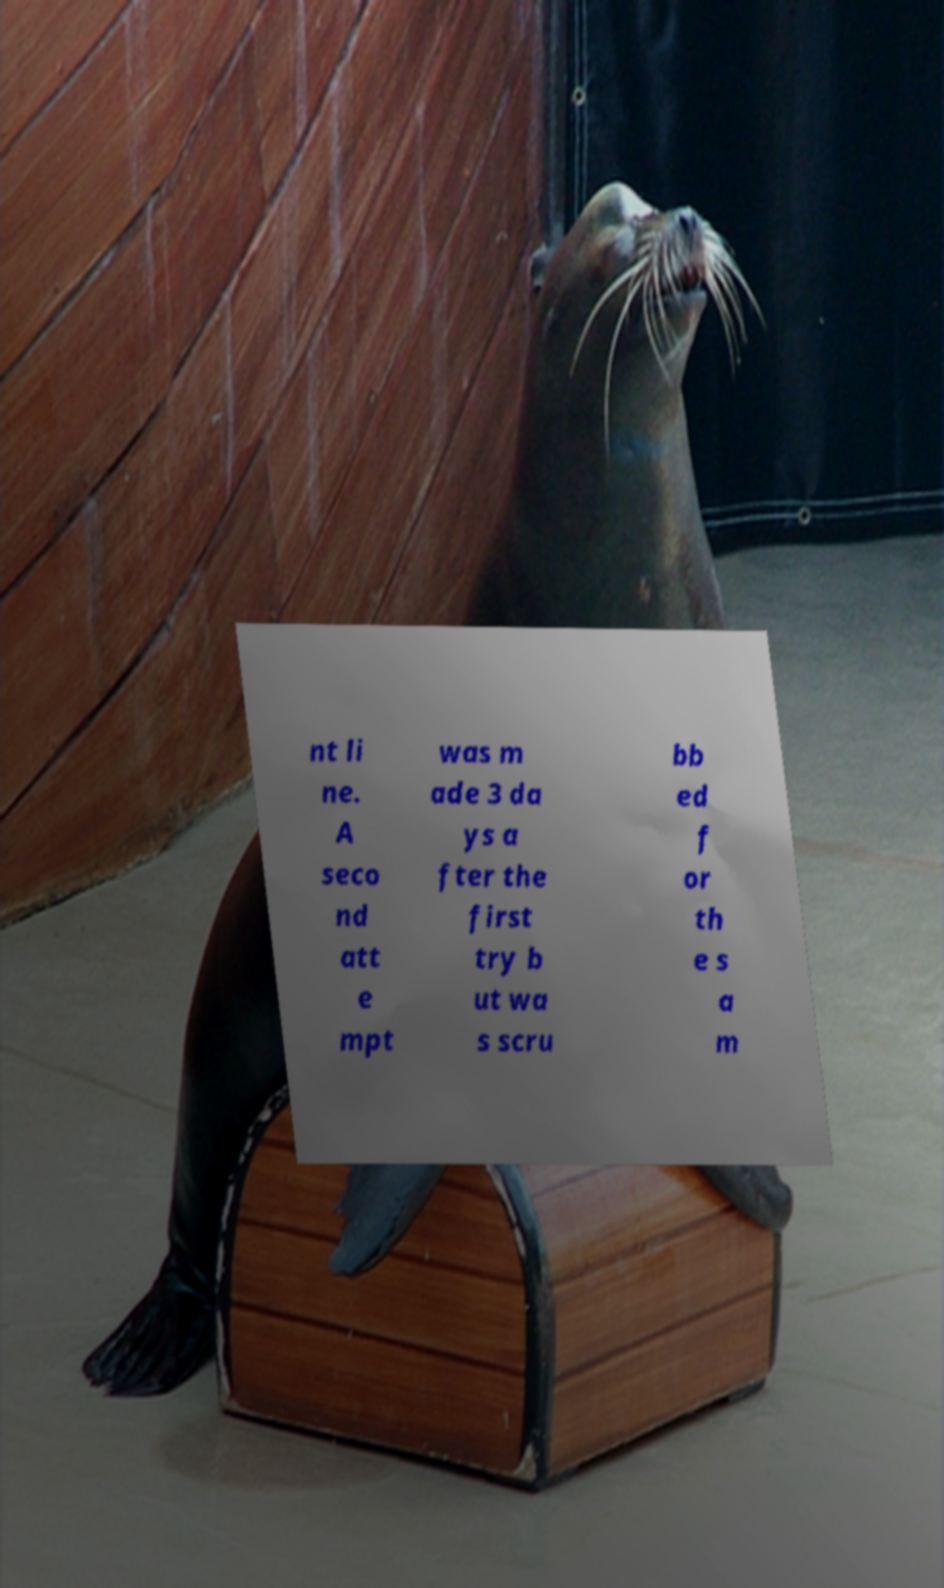Can you read and provide the text displayed in the image?This photo seems to have some interesting text. Can you extract and type it out for me? nt li ne. A seco nd att e mpt was m ade 3 da ys a fter the first try b ut wa s scru bb ed f or th e s a m 